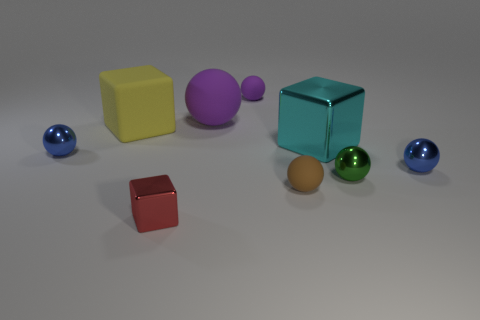Subtract all brown balls. How many balls are left? 5 Subtract all purple balls. How many balls are left? 4 Subtract all red spheres. Subtract all cyan cubes. How many spheres are left? 6 Add 1 purple spheres. How many objects exist? 10 Subtract all balls. How many objects are left? 3 Subtract all small blue spheres. Subtract all cubes. How many objects are left? 4 Add 3 spheres. How many spheres are left? 9 Add 3 brown matte balls. How many brown matte balls exist? 4 Subtract 0 blue cylinders. How many objects are left? 9 